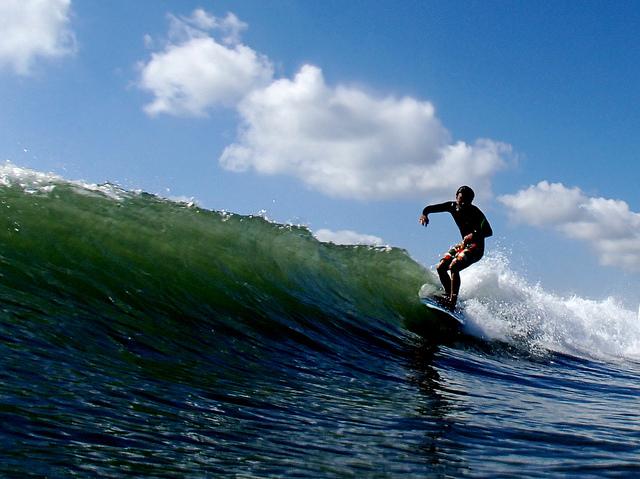Is the surfer wiping out?
Write a very short answer. No. Is the photographer in the water?
Give a very brief answer. Yes. What is the person doing?
Short answer required. Surfing. Is the man emerging from under the water?
Quick response, please. No. What color is the man?
Answer briefly. White. How high is the wave?
Quick response, please. 5 feet. How many wheels are visible?
Short answer required. 0. Is this a surfer?
Write a very short answer. Yes. What sport is this?
Answer briefly. Surfing. Does the man have long hair?
Be succinct. No. Was the wave too much for the man?
Be succinct. No. What is the man doing?
Short answer required. Surfing. What color is the board?
Write a very short answer. Blue. 